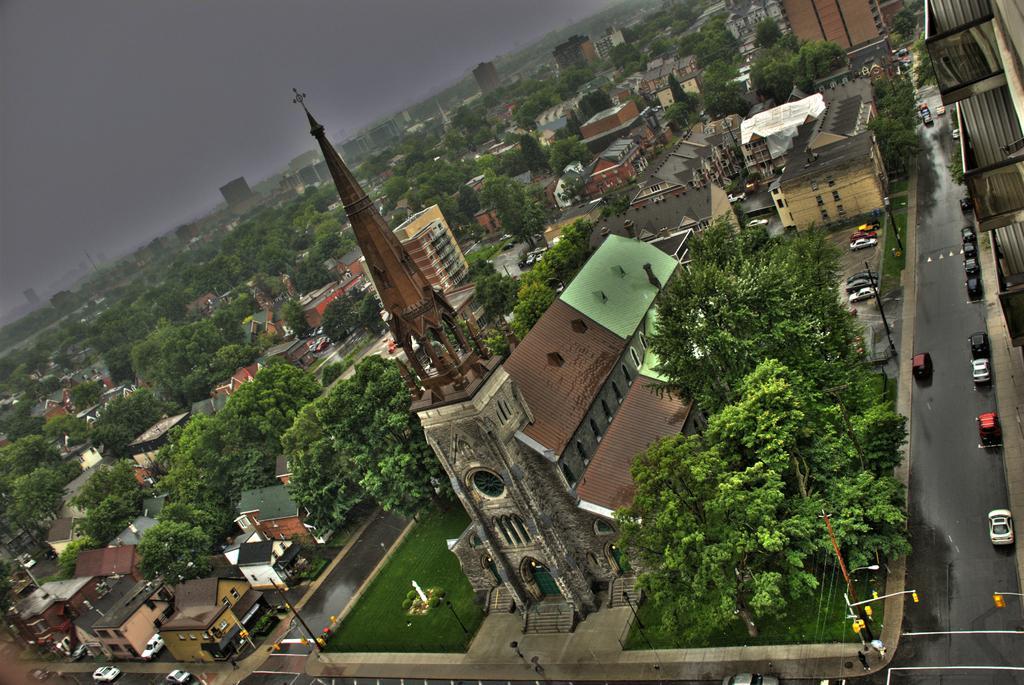Describe this image in one or two sentences. In the image there are many trees and also there are many buildings with walls, windows, pillars and roofs. And also there is a pole with a cross. On the roads there are many vehicles. And also there are poles. In the top left corner of the image there is sky with clouds. 